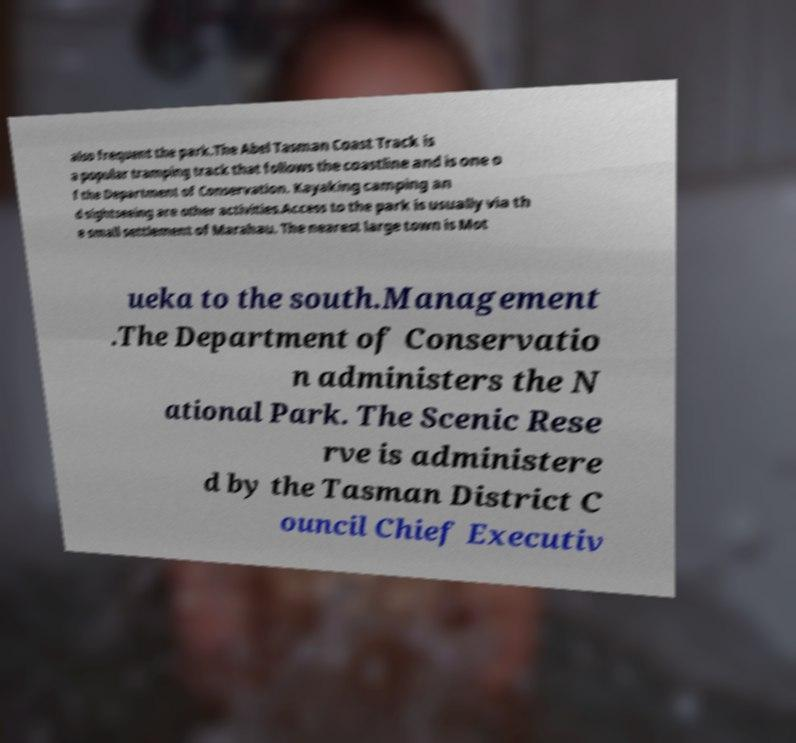For documentation purposes, I need the text within this image transcribed. Could you provide that? also frequent the park.The Abel Tasman Coast Track is a popular tramping track that follows the coastline and is one o f the Department of Conservation. Kayaking camping an d sightseeing are other activities.Access to the park is usually via th e small settlement of Marahau. The nearest large town is Mot ueka to the south.Management .The Department of Conservatio n administers the N ational Park. The Scenic Rese rve is administere d by the Tasman District C ouncil Chief Executiv 